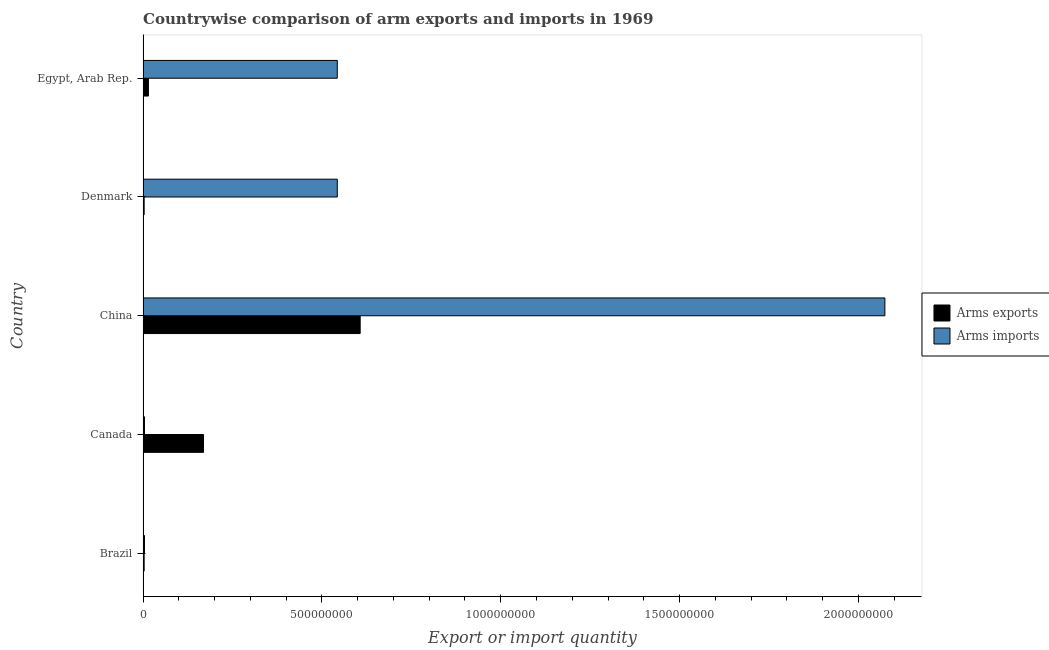How many groups of bars are there?
Give a very brief answer. 5. Are the number of bars per tick equal to the number of legend labels?
Offer a terse response. Yes. How many bars are there on the 5th tick from the top?
Your answer should be very brief. 2. How many bars are there on the 2nd tick from the bottom?
Give a very brief answer. 2. In how many cases, is the number of bars for a given country not equal to the number of legend labels?
Provide a succinct answer. 0. What is the arms exports in Canada?
Offer a very short reply. 1.69e+08. Across all countries, what is the maximum arms exports?
Keep it short and to the point. 6.07e+08. Across all countries, what is the minimum arms exports?
Offer a very short reply. 3.00e+06. In which country was the arms exports minimum?
Ensure brevity in your answer.  Brazil. What is the total arms exports in the graph?
Ensure brevity in your answer.  7.97e+08. What is the difference between the arms imports in Brazil and that in Denmark?
Keep it short and to the point. -5.39e+08. What is the difference between the arms exports in Brazil and the arms imports in Denmark?
Your answer should be compact. -5.40e+08. What is the average arms imports per country?
Offer a terse response. 6.34e+08. What is the difference between the arms imports and arms exports in Canada?
Keep it short and to the point. -1.65e+08. What is the ratio of the arms exports in China to that in Denmark?
Make the answer very short. 202.33. Is the arms imports in Canada less than that in China?
Your response must be concise. Yes. What is the difference between the highest and the second highest arms exports?
Your response must be concise. 4.38e+08. What is the difference between the highest and the lowest arms exports?
Make the answer very short. 6.04e+08. In how many countries, is the arms imports greater than the average arms imports taken over all countries?
Ensure brevity in your answer.  1. Is the sum of the arms exports in Brazil and Denmark greater than the maximum arms imports across all countries?
Ensure brevity in your answer.  No. What does the 1st bar from the top in Brazil represents?
Keep it short and to the point. Arms imports. What does the 2nd bar from the bottom in Canada represents?
Give a very brief answer. Arms imports. How many bars are there?
Your answer should be very brief. 10. Are all the bars in the graph horizontal?
Provide a short and direct response. Yes. Does the graph contain grids?
Give a very brief answer. No. How many legend labels are there?
Provide a short and direct response. 2. How are the legend labels stacked?
Offer a very short reply. Vertical. What is the title of the graph?
Provide a short and direct response. Countrywise comparison of arm exports and imports in 1969. Does "Private credit bureau" appear as one of the legend labels in the graph?
Your answer should be very brief. No. What is the label or title of the X-axis?
Ensure brevity in your answer.  Export or import quantity. What is the Export or import quantity in Arms exports in Canada?
Ensure brevity in your answer.  1.69e+08. What is the Export or import quantity in Arms exports in China?
Provide a succinct answer. 6.07e+08. What is the Export or import quantity of Arms imports in China?
Make the answer very short. 2.07e+09. What is the Export or import quantity in Arms imports in Denmark?
Your answer should be compact. 5.43e+08. What is the Export or import quantity of Arms exports in Egypt, Arab Rep.?
Provide a short and direct response. 1.50e+07. What is the Export or import quantity in Arms imports in Egypt, Arab Rep.?
Provide a succinct answer. 5.43e+08. Across all countries, what is the maximum Export or import quantity in Arms exports?
Give a very brief answer. 6.07e+08. Across all countries, what is the maximum Export or import quantity in Arms imports?
Offer a terse response. 2.07e+09. What is the total Export or import quantity of Arms exports in the graph?
Your answer should be compact. 7.97e+08. What is the total Export or import quantity of Arms imports in the graph?
Give a very brief answer. 3.17e+09. What is the difference between the Export or import quantity in Arms exports in Brazil and that in Canada?
Your answer should be very brief. -1.66e+08. What is the difference between the Export or import quantity in Arms exports in Brazil and that in China?
Provide a short and direct response. -6.04e+08. What is the difference between the Export or import quantity of Arms imports in Brazil and that in China?
Your answer should be very brief. -2.07e+09. What is the difference between the Export or import quantity of Arms imports in Brazil and that in Denmark?
Make the answer very short. -5.39e+08. What is the difference between the Export or import quantity of Arms exports in Brazil and that in Egypt, Arab Rep.?
Your answer should be very brief. -1.20e+07. What is the difference between the Export or import quantity in Arms imports in Brazil and that in Egypt, Arab Rep.?
Your answer should be very brief. -5.39e+08. What is the difference between the Export or import quantity in Arms exports in Canada and that in China?
Your answer should be very brief. -4.38e+08. What is the difference between the Export or import quantity in Arms imports in Canada and that in China?
Offer a very short reply. -2.07e+09. What is the difference between the Export or import quantity of Arms exports in Canada and that in Denmark?
Provide a succinct answer. 1.66e+08. What is the difference between the Export or import quantity in Arms imports in Canada and that in Denmark?
Your answer should be very brief. -5.39e+08. What is the difference between the Export or import quantity of Arms exports in Canada and that in Egypt, Arab Rep.?
Your response must be concise. 1.54e+08. What is the difference between the Export or import quantity of Arms imports in Canada and that in Egypt, Arab Rep.?
Give a very brief answer. -5.39e+08. What is the difference between the Export or import quantity in Arms exports in China and that in Denmark?
Offer a terse response. 6.04e+08. What is the difference between the Export or import quantity of Arms imports in China and that in Denmark?
Offer a very short reply. 1.53e+09. What is the difference between the Export or import quantity in Arms exports in China and that in Egypt, Arab Rep.?
Offer a terse response. 5.92e+08. What is the difference between the Export or import quantity in Arms imports in China and that in Egypt, Arab Rep.?
Make the answer very short. 1.53e+09. What is the difference between the Export or import quantity of Arms exports in Denmark and that in Egypt, Arab Rep.?
Your answer should be very brief. -1.20e+07. What is the difference between the Export or import quantity of Arms exports in Brazil and the Export or import quantity of Arms imports in Canada?
Keep it short and to the point. -1.00e+06. What is the difference between the Export or import quantity in Arms exports in Brazil and the Export or import quantity in Arms imports in China?
Make the answer very short. -2.07e+09. What is the difference between the Export or import quantity of Arms exports in Brazil and the Export or import quantity of Arms imports in Denmark?
Your answer should be very brief. -5.40e+08. What is the difference between the Export or import quantity in Arms exports in Brazil and the Export or import quantity in Arms imports in Egypt, Arab Rep.?
Keep it short and to the point. -5.40e+08. What is the difference between the Export or import quantity of Arms exports in Canada and the Export or import quantity of Arms imports in China?
Give a very brief answer. -1.90e+09. What is the difference between the Export or import quantity of Arms exports in Canada and the Export or import quantity of Arms imports in Denmark?
Your answer should be compact. -3.74e+08. What is the difference between the Export or import quantity of Arms exports in Canada and the Export or import quantity of Arms imports in Egypt, Arab Rep.?
Provide a short and direct response. -3.74e+08. What is the difference between the Export or import quantity of Arms exports in China and the Export or import quantity of Arms imports in Denmark?
Offer a terse response. 6.40e+07. What is the difference between the Export or import quantity in Arms exports in China and the Export or import quantity in Arms imports in Egypt, Arab Rep.?
Provide a succinct answer. 6.40e+07. What is the difference between the Export or import quantity in Arms exports in Denmark and the Export or import quantity in Arms imports in Egypt, Arab Rep.?
Offer a very short reply. -5.40e+08. What is the average Export or import quantity in Arms exports per country?
Your response must be concise. 1.59e+08. What is the average Export or import quantity in Arms imports per country?
Ensure brevity in your answer.  6.34e+08. What is the difference between the Export or import quantity of Arms exports and Export or import quantity of Arms imports in Brazil?
Provide a short and direct response. -1.00e+06. What is the difference between the Export or import quantity in Arms exports and Export or import quantity in Arms imports in Canada?
Keep it short and to the point. 1.65e+08. What is the difference between the Export or import quantity in Arms exports and Export or import quantity in Arms imports in China?
Your answer should be very brief. -1.47e+09. What is the difference between the Export or import quantity of Arms exports and Export or import quantity of Arms imports in Denmark?
Provide a short and direct response. -5.40e+08. What is the difference between the Export or import quantity in Arms exports and Export or import quantity in Arms imports in Egypt, Arab Rep.?
Give a very brief answer. -5.28e+08. What is the ratio of the Export or import quantity of Arms exports in Brazil to that in Canada?
Your answer should be compact. 0.02. What is the ratio of the Export or import quantity of Arms exports in Brazil to that in China?
Provide a short and direct response. 0. What is the ratio of the Export or import quantity in Arms imports in Brazil to that in China?
Make the answer very short. 0. What is the ratio of the Export or import quantity in Arms exports in Brazil to that in Denmark?
Offer a very short reply. 1. What is the ratio of the Export or import quantity of Arms imports in Brazil to that in Denmark?
Your response must be concise. 0.01. What is the ratio of the Export or import quantity in Arms imports in Brazil to that in Egypt, Arab Rep.?
Offer a very short reply. 0.01. What is the ratio of the Export or import quantity in Arms exports in Canada to that in China?
Provide a short and direct response. 0.28. What is the ratio of the Export or import quantity of Arms imports in Canada to that in China?
Offer a terse response. 0. What is the ratio of the Export or import quantity in Arms exports in Canada to that in Denmark?
Ensure brevity in your answer.  56.33. What is the ratio of the Export or import quantity of Arms imports in Canada to that in Denmark?
Your answer should be compact. 0.01. What is the ratio of the Export or import quantity of Arms exports in Canada to that in Egypt, Arab Rep.?
Your answer should be compact. 11.27. What is the ratio of the Export or import quantity of Arms imports in Canada to that in Egypt, Arab Rep.?
Offer a very short reply. 0.01. What is the ratio of the Export or import quantity of Arms exports in China to that in Denmark?
Your response must be concise. 202.33. What is the ratio of the Export or import quantity in Arms imports in China to that in Denmark?
Provide a short and direct response. 3.82. What is the ratio of the Export or import quantity of Arms exports in China to that in Egypt, Arab Rep.?
Give a very brief answer. 40.47. What is the ratio of the Export or import quantity of Arms imports in China to that in Egypt, Arab Rep.?
Your answer should be compact. 3.82. What is the ratio of the Export or import quantity in Arms imports in Denmark to that in Egypt, Arab Rep.?
Offer a very short reply. 1. What is the difference between the highest and the second highest Export or import quantity in Arms exports?
Give a very brief answer. 4.38e+08. What is the difference between the highest and the second highest Export or import quantity of Arms imports?
Make the answer very short. 1.53e+09. What is the difference between the highest and the lowest Export or import quantity in Arms exports?
Provide a short and direct response. 6.04e+08. What is the difference between the highest and the lowest Export or import quantity in Arms imports?
Your response must be concise. 2.07e+09. 